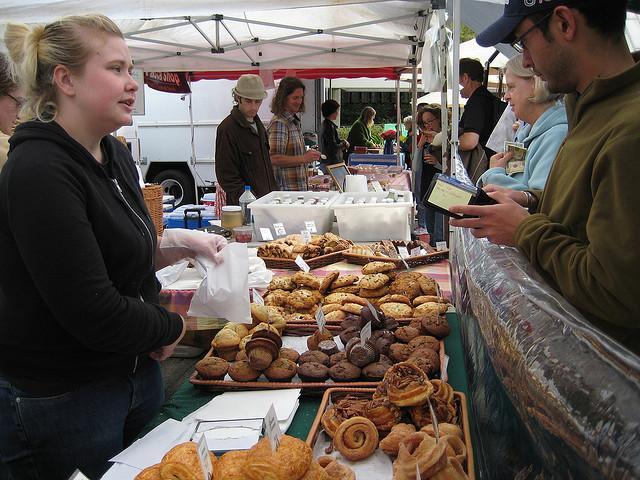How many people are there?
Give a very brief answer. 7. 